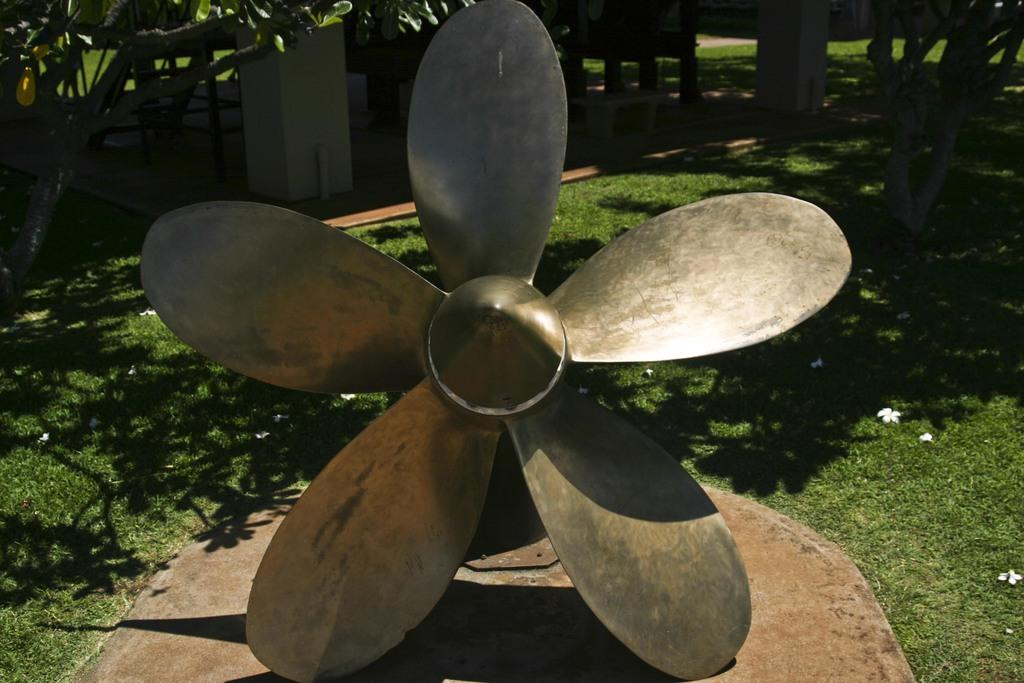What type of object is in the image that provides air circulation? There is a metal fan in the image. Where is the metal fan located? The metal fan is on a solid surface. What type of natural environment can be seen in the image? There is grass, trees, and white flowers visible in the image. What type of seating is present in the image? There is a bench in the image. What is the name of the daughter who is playing with the sail in the image? There is no daughter or sail present in the image. 